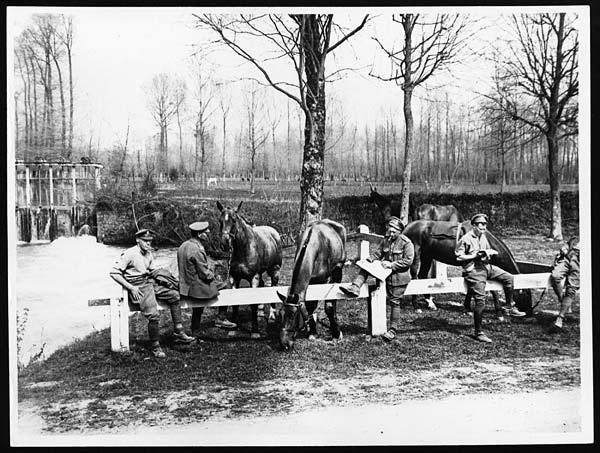How many people are pictured?
Give a very brief answer. 5. How many horses are visible?
Give a very brief answer. 3. How many people are there?
Give a very brief answer. 4. 